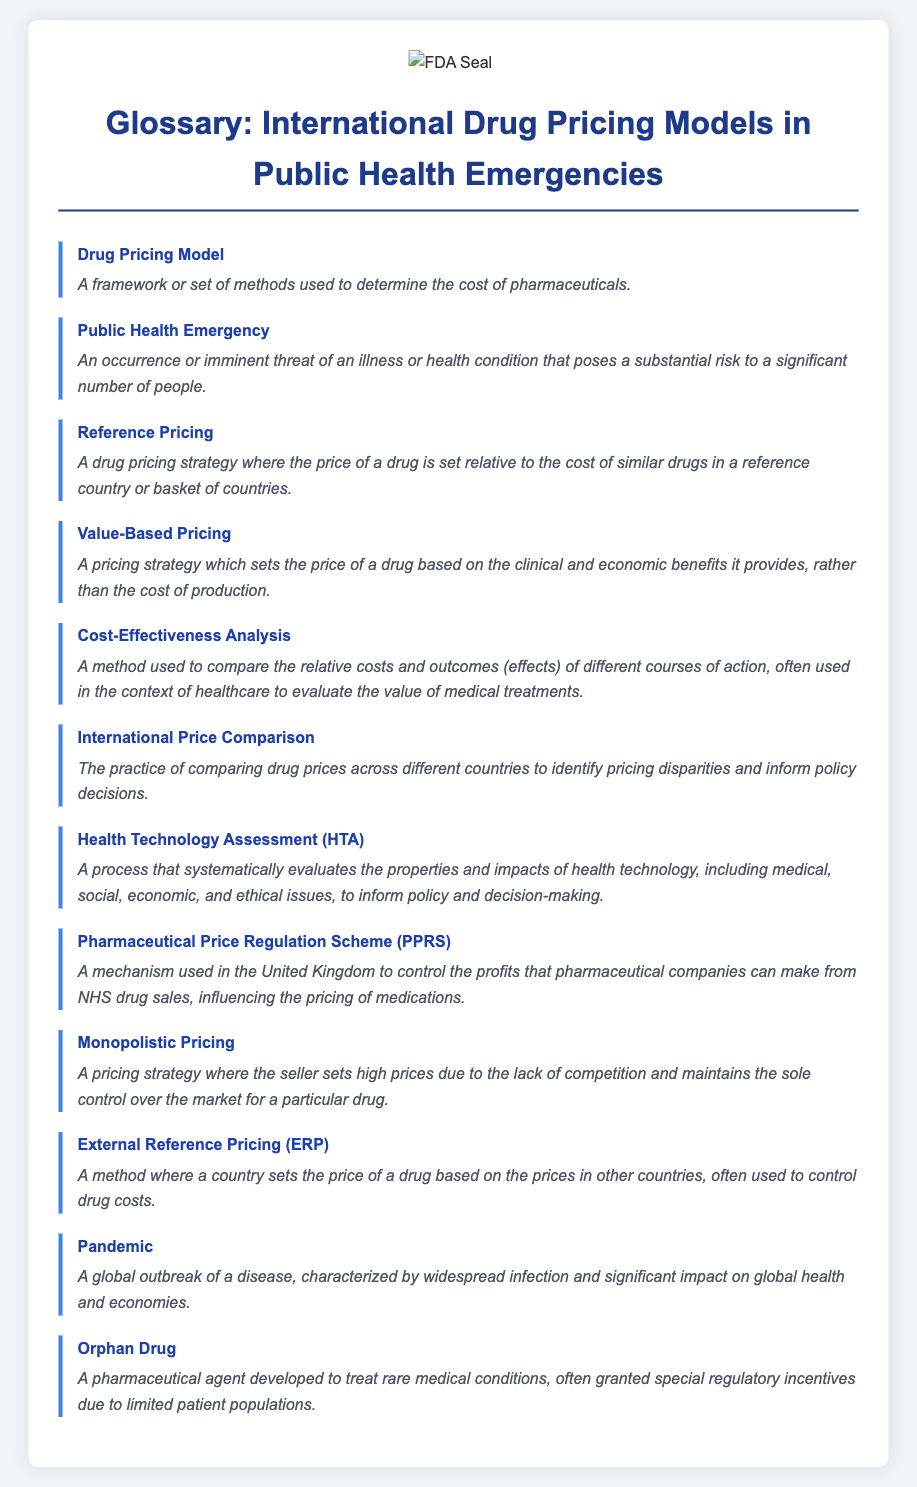What is a Drug Pricing Model? A Drug Pricing Model is a framework or set of methods used to determine the cost of pharmaceuticals.
Answer: A framework or set of methods used to determine the cost of pharmaceuticals What does Public Health Emergency refer to? Public Health Emergency refers to an occurrence or imminent threat of an illness or health condition that poses a substantial risk to a significant number of people.
Answer: An occurrence or imminent threat of an illness or health condition that poses a substantial risk to a significant number of people What is Reference Pricing? Reference Pricing is a drug pricing strategy where the price of a drug is set relative to the cost of similar drugs in a reference country or basket of countries.
Answer: A drug pricing strategy where the price of a drug is set relative to the cost of similar drugs in a reference country or basket of countries What pricing strategy sets prices based on clinical and economic benefits? Value-Based Pricing is the pricing strategy that sets the price of a drug based on the clinical and economic benefits it provides, rather than the cost of production.
Answer: Value-Based Pricing What is Cost-Effectiveness Analysis? Cost-Effectiveness Analysis is a method used to compare the relative costs and outcomes of different courses of action, often in healthcare.
Answer: A method used to compare the relative costs and outcomes of different courses of action What does Health Technology Assessment evaluate? Health Technology Assessment evaluates the properties and impacts of health technology, including medical, social, economic, and ethical issues.
Answer: The properties and impacts of health technology, including medical, social, economic, and ethical issues What is Monopolistic Pricing? Monopolistic Pricing is a pricing strategy where the seller sets high prices due to the lack of competition and maintains sole control over the market for a drug.
Answer: A pricing strategy where the seller sets high prices due to the lack of competition What is an Orphan Drug? An Orphan Drug is a pharmaceutical agent developed to treat rare medical conditions, often granted special regulatory incentives.
Answer: A pharmaceutical agent developed to treat rare medical conditions 